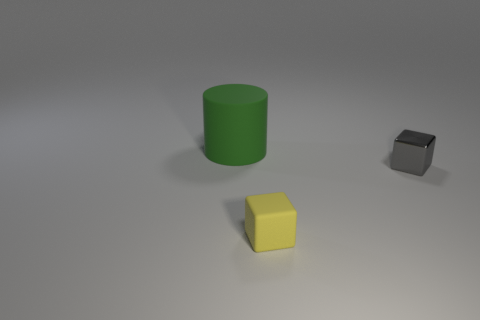There is a rubber object in front of the tiny metal cube; is its shape the same as the gray object?
Your answer should be very brief. Yes. The rubber object in front of the thing on the left side of the matte object that is in front of the rubber cylinder is what color?
Make the answer very short. Yellow. Are any gray blocks visible?
Provide a short and direct response. Yes. What number of other things are the same size as the green matte cylinder?
Your response must be concise. 0. There is a large rubber cylinder; does it have the same color as the matte thing to the right of the matte cylinder?
Keep it short and to the point. No. How many things are yellow things or tiny red matte objects?
Keep it short and to the point. 1. Does the gray cube have the same material as the small thing in front of the gray cube?
Provide a short and direct response. No. The rubber object left of the tiny object in front of the metallic block is what shape?
Your answer should be compact. Cylinder. What shape is the object that is behind the tiny matte object and on the left side of the small gray object?
Your answer should be very brief. Cylinder. What number of things are either big green rubber cylinders or yellow rubber blocks in front of the gray metallic block?
Your response must be concise. 2. 